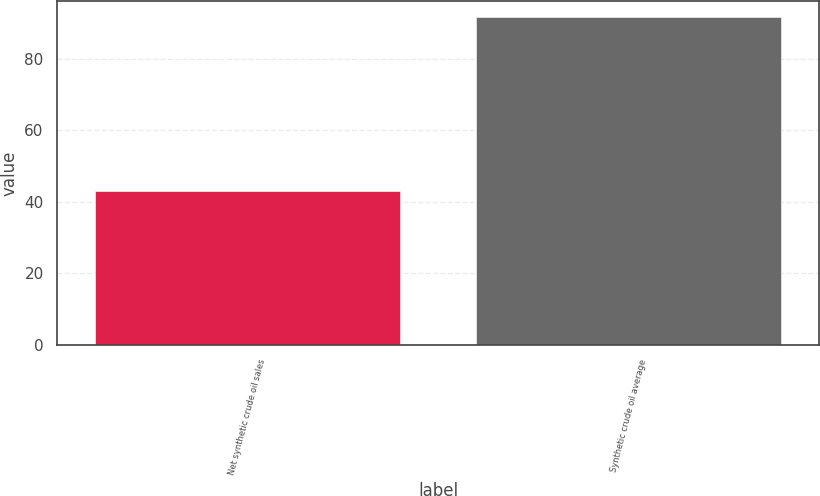Convert chart. <chart><loc_0><loc_0><loc_500><loc_500><bar_chart><fcel>Net synthetic crude oil sales<fcel>Synthetic crude oil average<nl><fcel>43<fcel>91.65<nl></chart> 